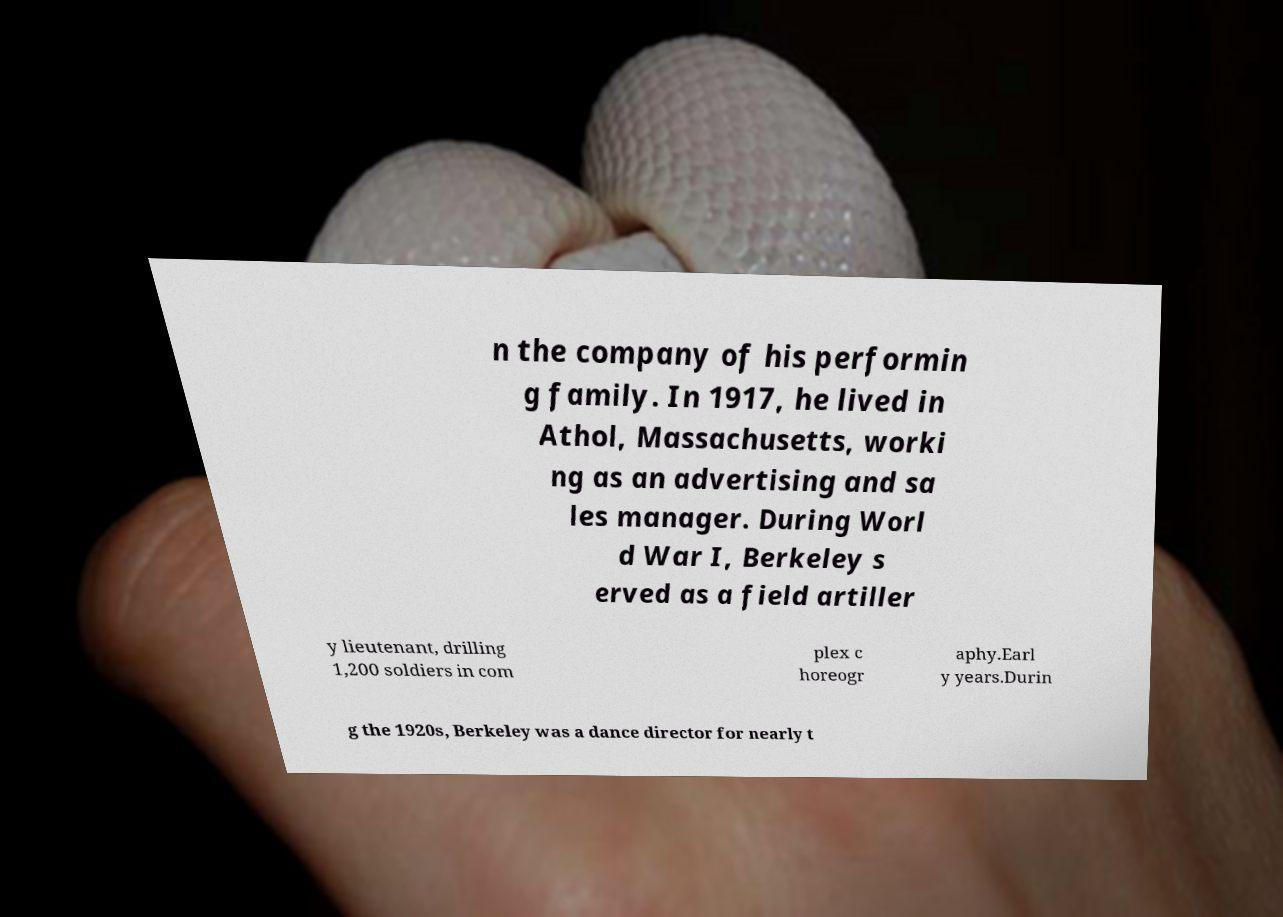There's text embedded in this image that I need extracted. Can you transcribe it verbatim? n the company of his performin g family. In 1917, he lived in Athol, Massachusetts, worki ng as an advertising and sa les manager. During Worl d War I, Berkeley s erved as a field artiller y lieutenant, drilling 1,200 soldiers in com plex c horeogr aphy.Earl y years.Durin g the 1920s, Berkeley was a dance director for nearly t 